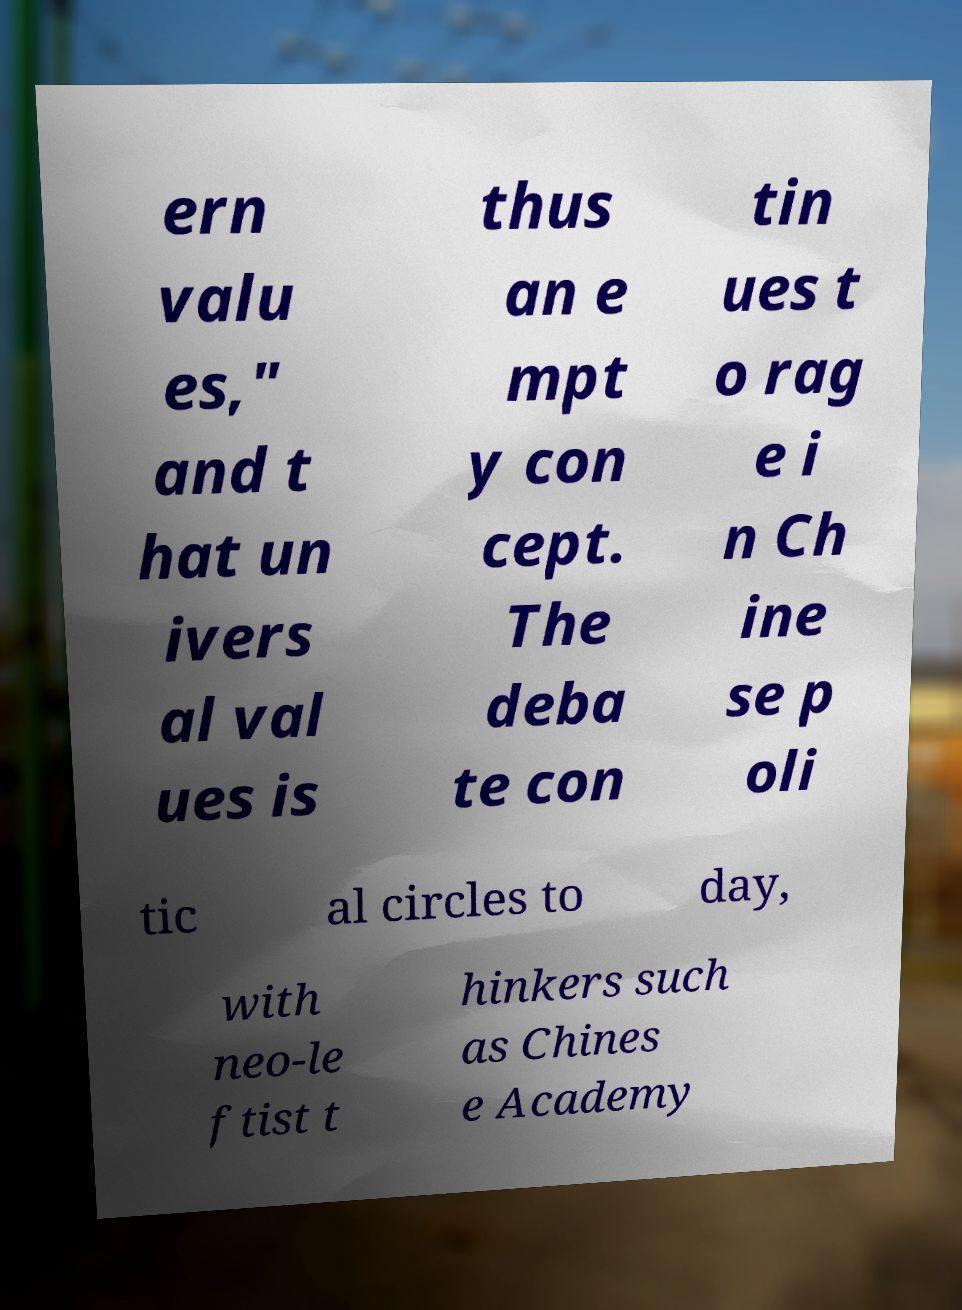I need the written content from this picture converted into text. Can you do that? ern valu es," and t hat un ivers al val ues is thus an e mpt y con cept. The deba te con tin ues t o rag e i n Ch ine se p oli tic al circles to day, with neo-le ftist t hinkers such as Chines e Academy 